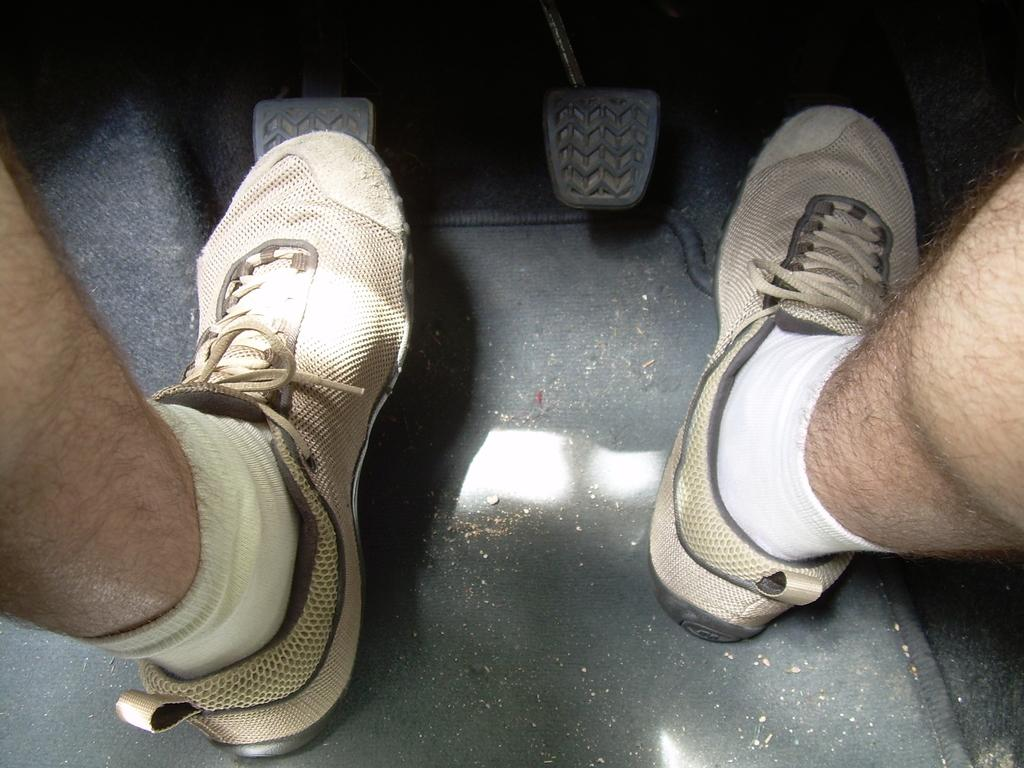What part of a person can be seen in the image? There is a person's leg visible in the image. What type of clothing is the person wearing on their feet? The person is wearing socks and shoes. Where is the image taken? The image shows the inside of a vehicle. What direction is the vehicle moving in? The image shows an acceleration towards the top of the image, indicating that the vehicle is moving forward. What type of waves can be seen in the image? There are no waves present in the image; it shows the inside of a vehicle with a person's leg visible. 